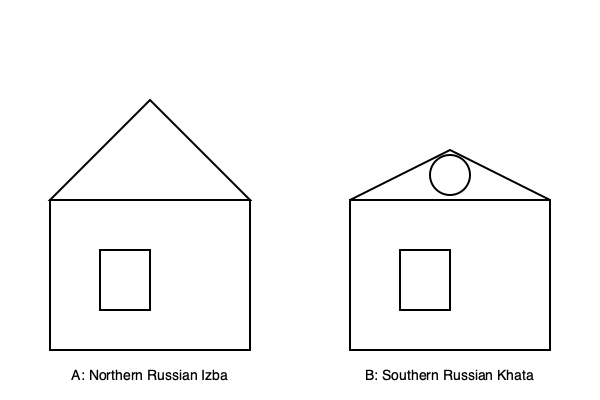Based on the architectural diagrams provided, which key feature distinguishes the Southern Russian Khata (B) from the Northern Russian Izba (A), reflecting the climatic and cultural differences between these regions? To answer this question, we need to analyze the key differences between the two architectural diagrams:

1. Roof structure:
   A (Northern Russian Izba): The roof has a steep pitch, forming an equilateral triangle.
   B (Southern Russian Khata): The roof has a gentler slope, creating an obtuse triangle.

2. Additional features:
   A: No additional features visible on the roof.
   B: There is a circular element on the roof, likely representing a chimney.

3. Wall height:
   Both structures have similar wall heights.

4. Window placement:
   Both have similarly placed windows.

The key distinguishing feature is the roof structure and the presence of a chimney. The Northern Russian Izba has a steeper roof to shed heavy snow loads typical in colder northern climates. The Southern Russian Khata has a gentler roof slope, suitable for the milder southern climate.

The circular element on the Khata's roof represents a chimney, which is a distinctive feature of southern Russian house designs. In northern Russia, heating systems were often smoke-free to retain warmth, while in the south, chimneys were more common due to less severe winters.

These differences reflect the climatic variations between northern and southern Russia and the resulting adaptations in traditional architecture.
Answer: Gentler roof slope and visible chimney 